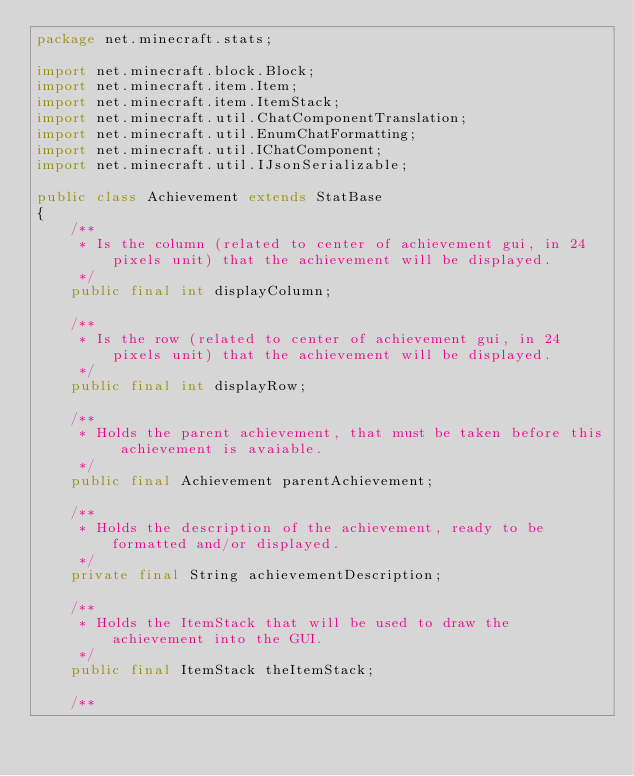<code> <loc_0><loc_0><loc_500><loc_500><_Java_>package net.minecraft.stats;

import net.minecraft.block.Block;
import net.minecraft.item.Item;
import net.minecraft.item.ItemStack;
import net.minecraft.util.ChatComponentTranslation;
import net.minecraft.util.EnumChatFormatting;
import net.minecraft.util.IChatComponent;
import net.minecraft.util.IJsonSerializable;

public class Achievement extends StatBase
{
    /**
     * Is the column (related to center of achievement gui, in 24 pixels unit) that the achievement will be displayed.
     */
    public final int displayColumn;

    /**
     * Is the row (related to center of achievement gui, in 24 pixels unit) that the achievement will be displayed.
     */
    public final int displayRow;

    /**
     * Holds the parent achievement, that must be taken before this achievement is avaiable.
     */
    public final Achievement parentAchievement;

    /**
     * Holds the description of the achievement, ready to be formatted and/or displayed.
     */
    private final String achievementDescription;

    /**
     * Holds the ItemStack that will be used to draw the achievement into the GUI.
     */
    public final ItemStack theItemStack;

    /**</code> 